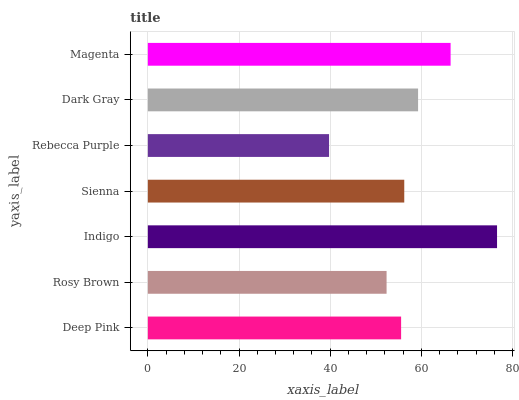Is Rebecca Purple the minimum?
Answer yes or no. Yes. Is Indigo the maximum?
Answer yes or no. Yes. Is Rosy Brown the minimum?
Answer yes or no. No. Is Rosy Brown the maximum?
Answer yes or no. No. Is Deep Pink greater than Rosy Brown?
Answer yes or no. Yes. Is Rosy Brown less than Deep Pink?
Answer yes or no. Yes. Is Rosy Brown greater than Deep Pink?
Answer yes or no. No. Is Deep Pink less than Rosy Brown?
Answer yes or no. No. Is Sienna the high median?
Answer yes or no. Yes. Is Sienna the low median?
Answer yes or no. Yes. Is Rebecca Purple the high median?
Answer yes or no. No. Is Magenta the low median?
Answer yes or no. No. 